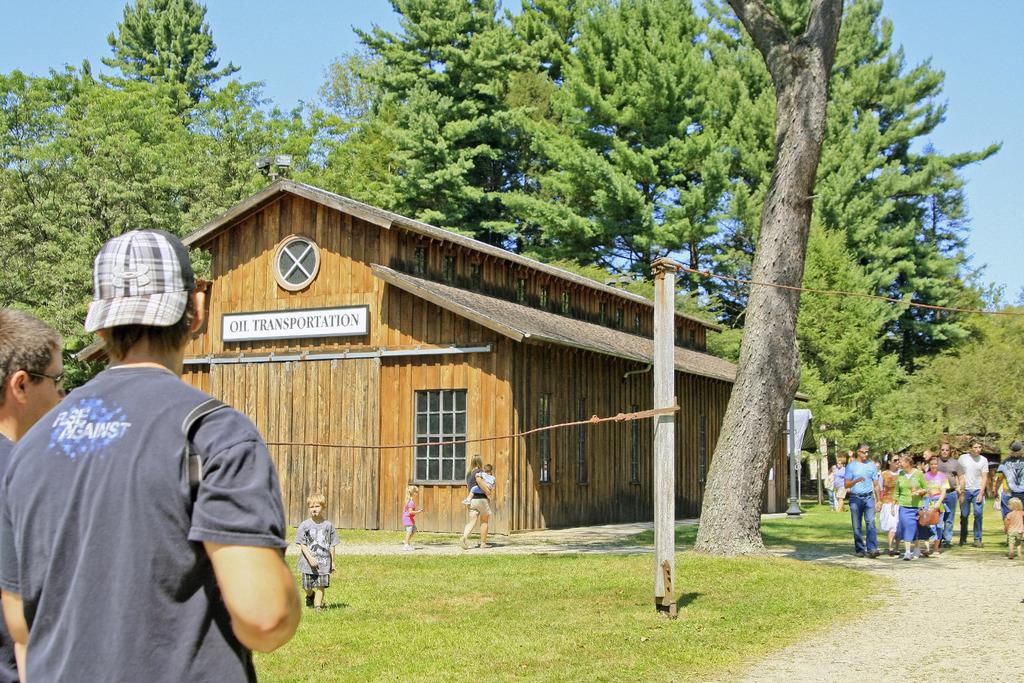How many men are standing on the left side of the image? There are two men standing on the left side of the image. What type of structure is in the middle of the image? There is a wooden house in the middle of the image. What are the people on the right side of the image doing? There is a group of people walking on the right side of the image. What type of vegetation can be seen in the image? There are trees visible in the image. What type of fuel is being used by the soup in the image? There is no soup or fuel present in the image. What is the afterthought of the people walking on the right side of the image? There is no indication of an afterthought in the image; it simply shows a group of people walking. 